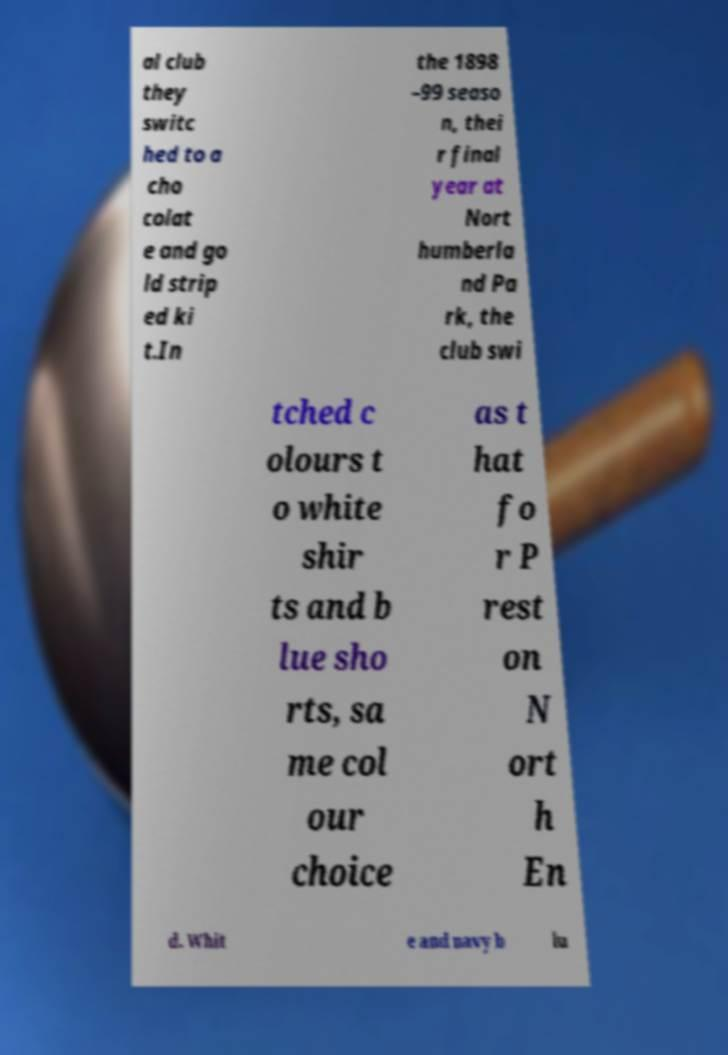For documentation purposes, I need the text within this image transcribed. Could you provide that? al club they switc hed to a cho colat e and go ld strip ed ki t.In the 1898 –99 seaso n, thei r final year at Nort humberla nd Pa rk, the club swi tched c olours t o white shir ts and b lue sho rts, sa me col our choice as t hat fo r P rest on N ort h En d. Whit e and navy b lu 